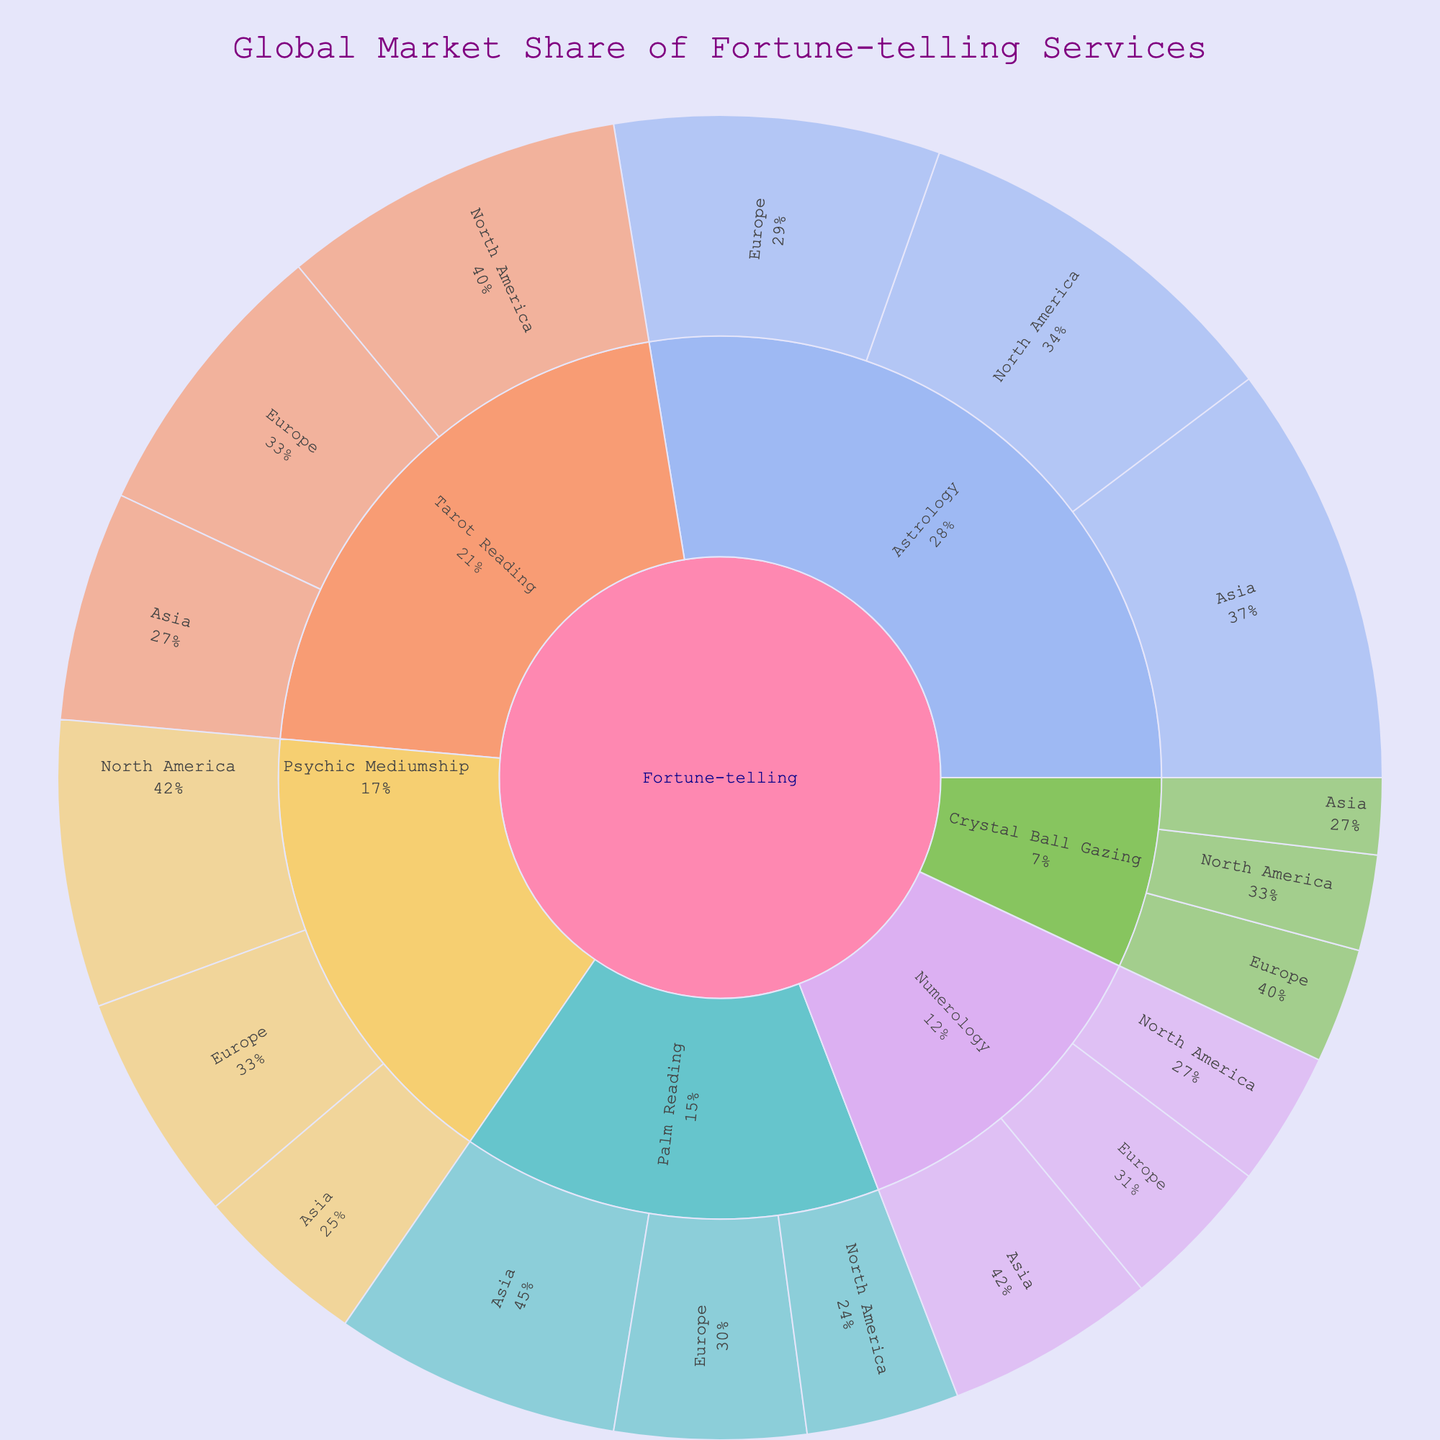What is the title of the figure? The title is usually displayed at the top of the figure. Look at the top to find it.
Answer: Global Market Share of Fortune-telling Services Which fortune-telling method has the highest market share in Asia? Inspect the sections under the 'Asia' node. Look for the method with the largest segment.
Answer: Astrology What is the total market share of Numerology across all regions? Sum the market shares of Numerology in North America, Europe, and Asia. That's 7 + 8 + 11.
Answer: 26 Which region contributes the most to the market share of Tarot Reading? Compare the market share percentages of Tarot Reading in North America, Europe, and Asia. Identify the highest value.
Answer: North America Is the market share of Crystal Ball Gazing higher in Europe or Asia? Compare the market share of Crystal Ball Gazing in Europe and Asia. Look for the higher number.
Answer: Europe What is the combined market share of Palm Reading in North America and Europe? Add the values of Palm Reading in North America and Europe. That's 8 + 10.
Answer: 18 Which fortune-telling method has the lowest market share in North America? Check all the segments under 'North America'. Identify the method with the smallest segment.
Answer: Crystal Ball Gazing How much greater is the market share of Astrology in Asia compared to Europe? Subtract the market share of Astrology in Europe from that in Asia. That's 22 - 17.
Answer: 5 Across all methods, which region seems to dominate the overall market share? Compare the total market shares of each region by summing their associated values. The region with the highest total is dominant.
Answer: North America What is the average market share of Psychic Mediumship across all regions? Sum the market shares of Psychic Mediumship in all regions and divide by the number of regions (3). That’s (15 + 12 + 9) / 3.
Answer: 12 